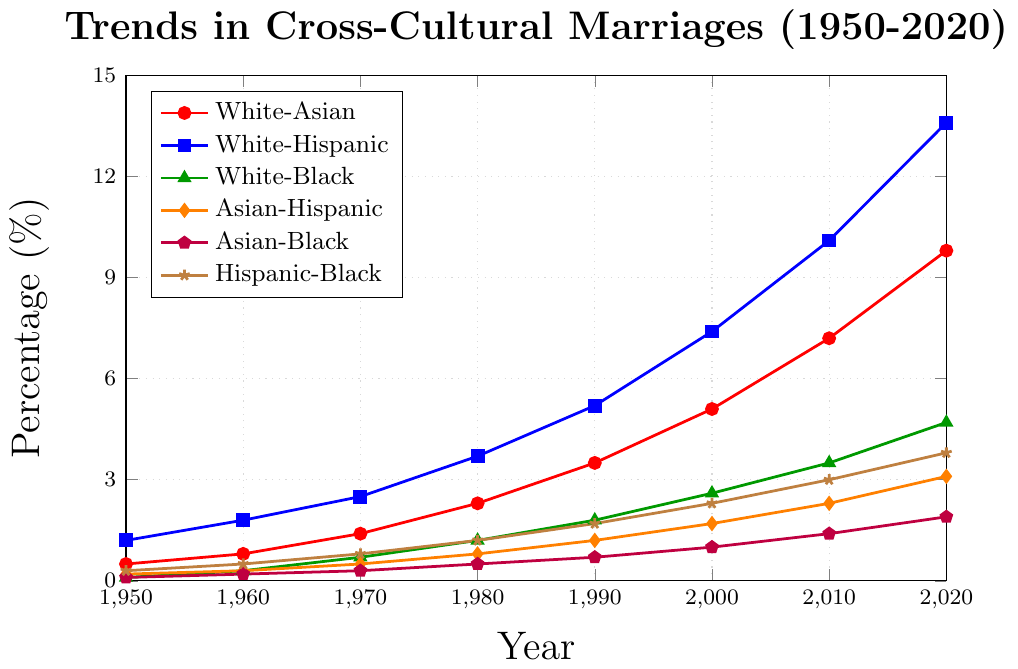What trend can you observe for White-Hispanic marriages between 1950 and 2020? To understand the trend for White-Hispanic marriages, observe the plotted line from 1950 to 2020. The line shows a steady increase from 1.2% in 1950 to 13.6% in 2020.
Answer: Steadily increasing In what year did White-Black marriages first surpass 1%? Look at the plotted line for White-Black marriages and identify when it exceeds the 1% mark. In 1980, the value is 1.2%, the first time it surpasses 1%.
Answer: 1980 Which group had the highest percentage of cross-cultural marriages in 2020? Examine the end points of each line for the year 2020. The White-Hispanic group has the highest percentage at 13.6%.
Answer: White-Hispanic How did the percentage of Asian-Hispanic marriages change from 1950 to 1960? Compare the Asian-Hispanic data points for the years 1950 (0.2%) and 1960 (0.3%). Subtract the 1950 value from the 1960 value (0.3% - 0.2% = 0.1%).
Answer: Increased by 0.1% By how much did the percentage of Hispanic-Black marriages increase from 2000 to 2020? Locate the points for Hispanic-Black marriages in 2000 (2.3%) and 2020 (3.8%). Subtract the 2000 value from the 2020 value (3.8% - 2.3% = 1.5%).
Answer: 1.5% What is the difference in the percentages of White-Asian and White-Black marriages in 2020? Compare the values for White-Asian (9.8%) and White-Black (4.7%) marriages in 2020. Subtract the White-Black value from the White-Asian value (9.8% - 4.7% = 5.1%).
Answer: 5.1% Which groups have seen their percentages increase by more than 5% from 1950 to 2020? Check the values for each group in 1950 and 2020. Calculate the change: White-Asian (9.3%), White-Hispanic (12.4%), White-Black (4.6%), Asian-Hispanic (2.9%), Asian-Black (1.8%), Hispanic-Black (3.5%). White-Asian and White-Hispanic have increased by more than 5%.
Answer: White-Asian, White-Hispanic What is the sum of the percentages for White-Hispanic and Hispanic-Black marriages in 2010? Find the 2010 values for White-Hispanic (10.1%) and Hispanic-Black (3.0%). Add them together (10.1% + 3.0% = 13.1%).
Answer: 13.1% Which group shows the least overall increase from 1950 to 2020? Calculate the increase for each group: White-Asian (9.3%), White-Hispanic (12.4%), White-Black (4.6%), Asian-Hispanic (2.9%), Asian-Black (1.8%), Hispanic-Black (3.5%). The smallest increase is for Asian-Black (1.8%).
Answer: Asian-Black 